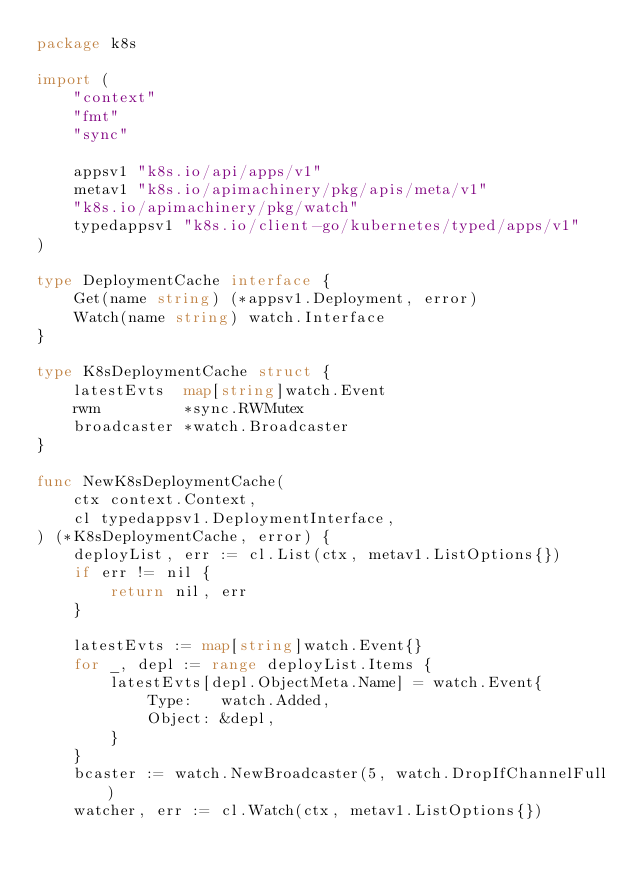<code> <loc_0><loc_0><loc_500><loc_500><_Go_>package k8s

import (
	"context"
	"fmt"
	"sync"

	appsv1 "k8s.io/api/apps/v1"
	metav1 "k8s.io/apimachinery/pkg/apis/meta/v1"
	"k8s.io/apimachinery/pkg/watch"
	typedappsv1 "k8s.io/client-go/kubernetes/typed/apps/v1"
)

type DeploymentCache interface {
	Get(name string) (*appsv1.Deployment, error)
	Watch(name string) watch.Interface
}

type K8sDeploymentCache struct {
	latestEvts  map[string]watch.Event
	rwm         *sync.RWMutex
	broadcaster *watch.Broadcaster
}

func NewK8sDeploymentCache(
	ctx context.Context,
	cl typedappsv1.DeploymentInterface,
) (*K8sDeploymentCache, error) {
	deployList, err := cl.List(ctx, metav1.ListOptions{})
	if err != nil {
		return nil, err
	}

	latestEvts := map[string]watch.Event{}
	for _, depl := range deployList.Items {
		latestEvts[depl.ObjectMeta.Name] = watch.Event{
			Type:   watch.Added,
			Object: &depl,
		}
	}
	bcaster := watch.NewBroadcaster(5, watch.DropIfChannelFull)
	watcher, err := cl.Watch(ctx, metav1.ListOptions{})</code> 